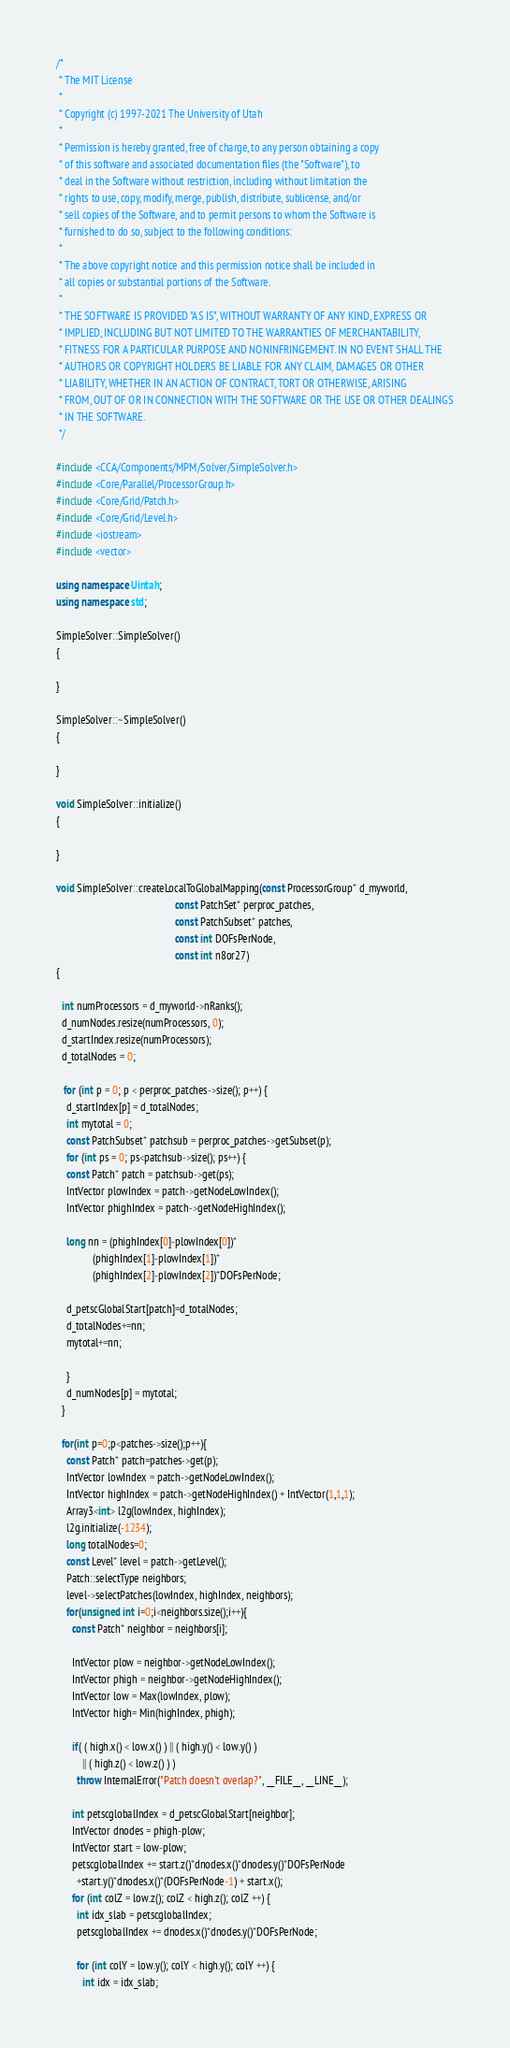<code> <loc_0><loc_0><loc_500><loc_500><_C++_>/*
 * The MIT License
 *
 * Copyright (c) 1997-2021 The University of Utah
 *
 * Permission is hereby granted, free of charge, to any person obtaining a copy
 * of this software and associated documentation files (the "Software"), to
 * deal in the Software without restriction, including without limitation the
 * rights to use, copy, modify, merge, publish, distribute, sublicense, and/or
 * sell copies of the Software, and to permit persons to whom the Software is
 * furnished to do so, subject to the following conditions:
 *
 * The above copyright notice and this permission notice shall be included in
 * all copies or substantial portions of the Software.
 *
 * THE SOFTWARE IS PROVIDED "AS IS", WITHOUT WARRANTY OF ANY KIND, EXPRESS OR
 * IMPLIED, INCLUDING BUT NOT LIMITED TO THE WARRANTIES OF MERCHANTABILITY,
 * FITNESS FOR A PARTICULAR PURPOSE AND NONINFRINGEMENT. IN NO EVENT SHALL THE
 * AUTHORS OR COPYRIGHT HOLDERS BE LIABLE FOR ANY CLAIM, DAMAGES OR OTHER
 * LIABILITY, WHETHER IN AN ACTION OF CONTRACT, TORT OR OTHERWISE, ARISING
 * FROM, OUT OF OR IN CONNECTION WITH THE SOFTWARE OR THE USE OR OTHER DEALINGS
 * IN THE SOFTWARE.
 */

#include <CCA/Components/MPM/Solver/SimpleSolver.h>
#include <Core/Parallel/ProcessorGroup.h>
#include <Core/Grid/Patch.h>
#include <Core/Grid/Level.h>
#include <iostream>
#include <vector>

using namespace Uintah;
using namespace std;

SimpleSolver::SimpleSolver()
{

}

SimpleSolver::~SimpleSolver()
{

}

void SimpleSolver::initialize()
{
  
}

void SimpleSolver::createLocalToGlobalMapping(const ProcessorGroup* d_myworld,
                                              const PatchSet* perproc_patches,
                                              const PatchSubset* patches,
                                              const int DOFsPerNode,
                                              const int n8or27)
{

  int numProcessors = d_myworld->nRanks();
  d_numNodes.resize(numProcessors, 0);
  d_startIndex.resize(numProcessors);
  d_totalNodes = 0;

   for (int p = 0; p < perproc_patches->size(); p++) {
    d_startIndex[p] = d_totalNodes;
    int mytotal = 0;
    const PatchSubset* patchsub = perproc_patches->getSubset(p);
    for (int ps = 0; ps<patchsub->size(); ps++) {
    const Patch* patch = patchsub->get(ps);
    IntVector plowIndex = patch->getNodeLowIndex();
    IntVector phighIndex = patch->getNodeHighIndex();

    long nn = (phighIndex[0]-plowIndex[0])*
              (phighIndex[1]-plowIndex[1])*
              (phighIndex[2]-plowIndex[2])*DOFsPerNode;

    d_petscGlobalStart[patch]=d_totalNodes;
    d_totalNodes+=nn;
    mytotal+=nn;
    
    }
    d_numNodes[p] = mytotal;
  }

  for(int p=0;p<patches->size();p++){
    const Patch* patch=patches->get(p);
    IntVector lowIndex = patch->getNodeLowIndex();
    IntVector highIndex = patch->getNodeHighIndex() + IntVector(1,1,1);
    Array3<int> l2g(lowIndex, highIndex);
    l2g.initialize(-1234);
    long totalNodes=0;
    const Level* level = patch->getLevel();
    Patch::selectType neighbors;
    level->selectPatches(lowIndex, highIndex, neighbors);
    for(unsigned int i=0;i<neighbors.size();i++){
      const Patch* neighbor = neighbors[i];
      
      IntVector plow = neighbor->getNodeLowIndex();
      IntVector phigh = neighbor->getNodeHighIndex();
      IntVector low = Max(lowIndex, plow);
      IntVector high= Min(highIndex, phigh);
      
      if( ( high.x() < low.x() ) || ( high.y() < low.y() ) 
          || ( high.z() < low.z() ) )
        throw InternalError("Patch doesn't overlap?", __FILE__, __LINE__);
      
      int petscglobalIndex = d_petscGlobalStart[neighbor];
      IntVector dnodes = phigh-plow;
      IntVector start = low-plow;
      petscglobalIndex += start.z()*dnodes.x()*dnodes.y()*DOFsPerNode
        +start.y()*dnodes.x()*(DOFsPerNode-1) + start.x();
      for (int colZ = low.z(); colZ < high.z(); colZ ++) {
        int idx_slab = petscglobalIndex;
        petscglobalIndex += dnodes.x()*dnodes.y()*DOFsPerNode;
        
        for (int colY = low.y(); colY < high.y(); colY ++) {
          int idx = idx_slab;</code> 